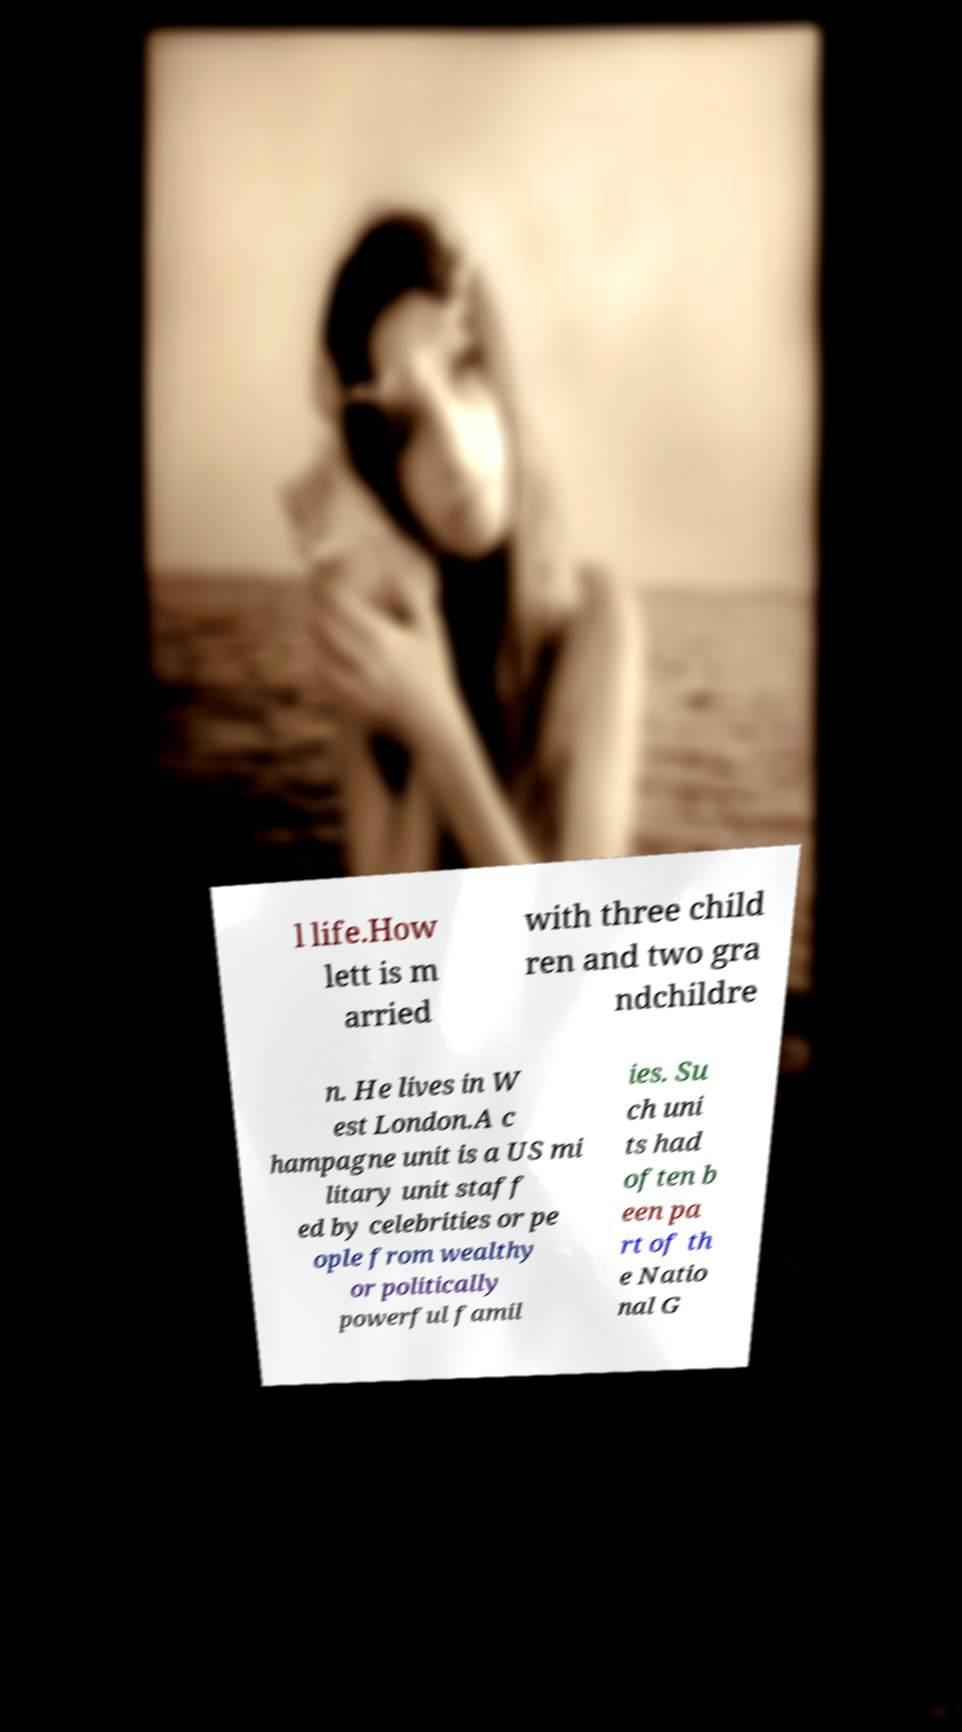For documentation purposes, I need the text within this image transcribed. Could you provide that? l life.How lett is m arried with three child ren and two gra ndchildre n. He lives in W est London.A c hampagne unit is a US mi litary unit staff ed by celebrities or pe ople from wealthy or politically powerful famil ies. Su ch uni ts had often b een pa rt of th e Natio nal G 